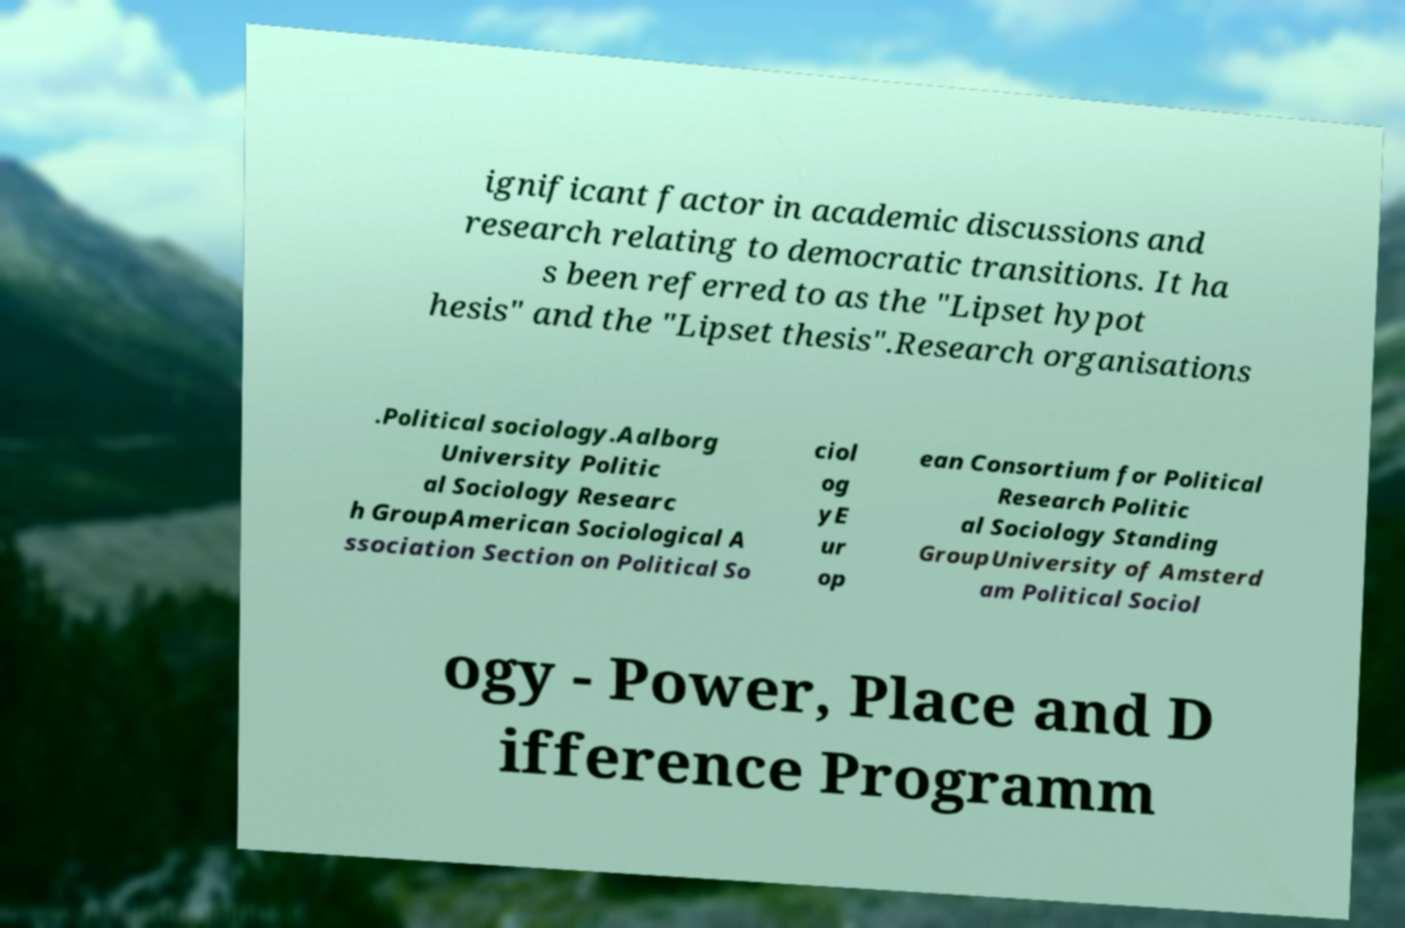For documentation purposes, I need the text within this image transcribed. Could you provide that? ignificant factor in academic discussions and research relating to democratic transitions. It ha s been referred to as the "Lipset hypot hesis" and the "Lipset thesis".Research organisations .Political sociology.Aalborg University Politic al Sociology Researc h GroupAmerican Sociological A ssociation Section on Political So ciol og yE ur op ean Consortium for Political Research Politic al Sociology Standing GroupUniversity of Amsterd am Political Sociol ogy - Power, Place and D ifference Programm 